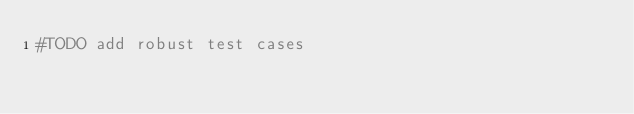Convert code to text. <code><loc_0><loc_0><loc_500><loc_500><_Python_>#TODO add robust test cases</code> 